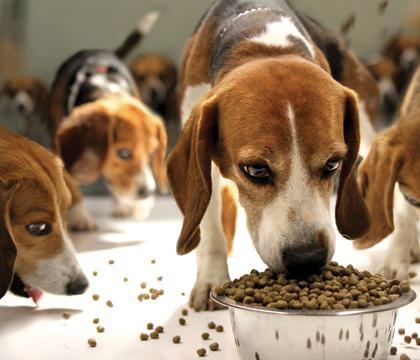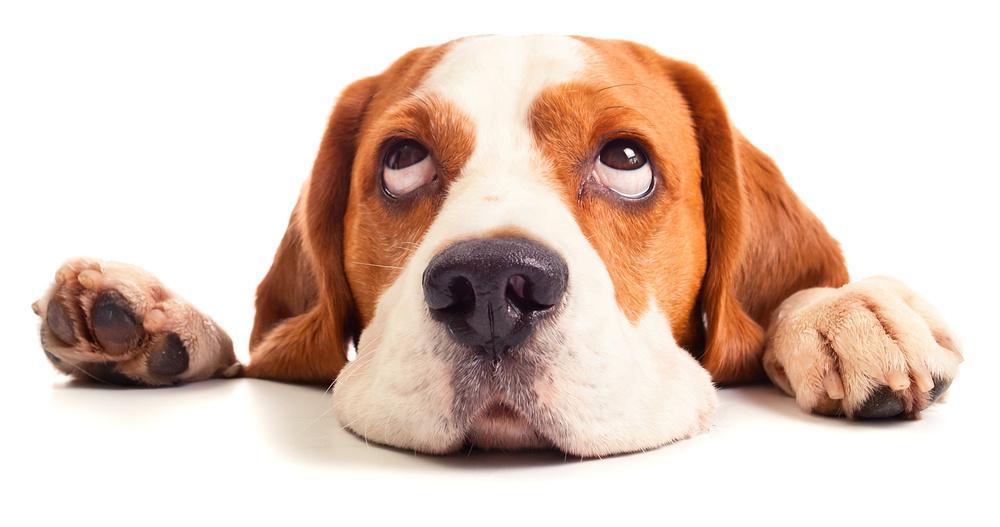The first image is the image on the left, the second image is the image on the right. For the images shown, is this caption "A single dog is lying down relaxing in the image on the right." true? Answer yes or no. Yes. The first image is the image on the left, the second image is the image on the right. Assess this claim about the two images: "An image shows a person's hand around at least one beagle dog.". Correct or not? Answer yes or no. No. 